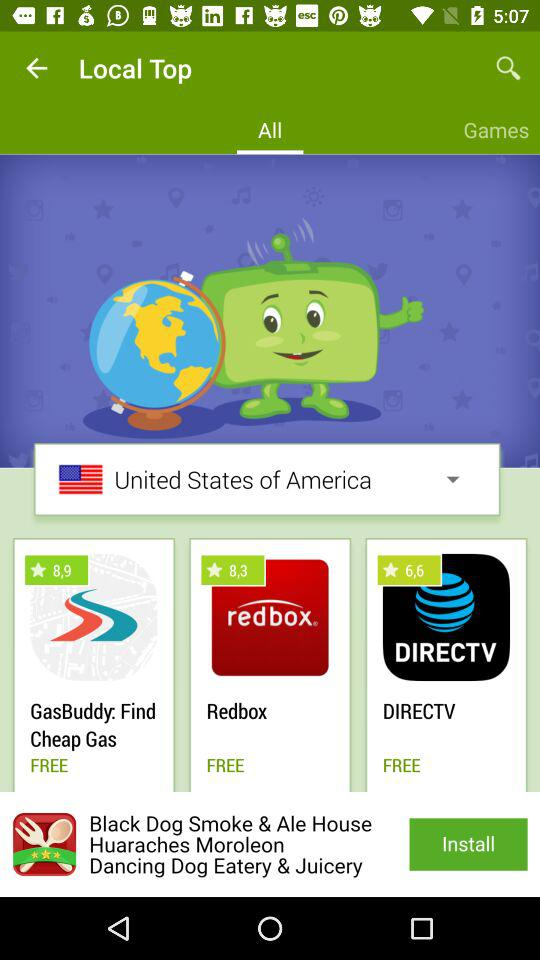How many of the apps are free?
Answer the question using a single word or phrase. 3 